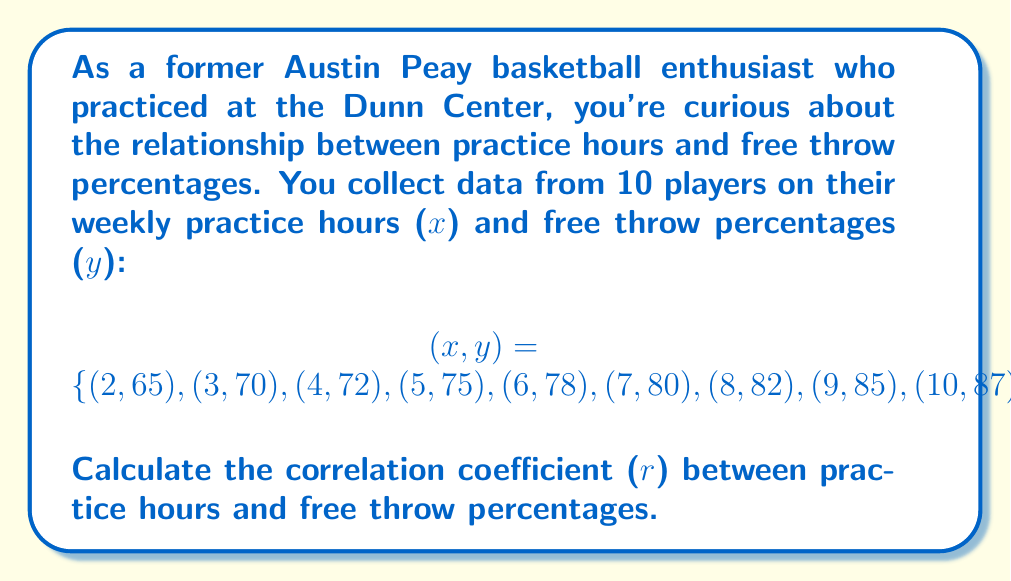Solve this math problem. To calculate the correlation coefficient (r), we'll use the formula:

$$r = \frac{n\sum xy - \sum x \sum y}{\sqrt{[n\sum x^2 - (\sum x)^2][n\sum y^2 - (\sum y)^2]}}$$

Step 1: Calculate the sums and squared sums:
$\sum x = 65$, $\sum y = 784$, $\sum xy = 5,434$
$\sum x^2 = 505$, $\sum y^2 = 62,230$

Step 2: Calculate $n\sum xy$:
$n\sum xy = 10 \times 5,434 = 54,340$

Step 3: Calculate $\sum x \sum y$:
$\sum x \sum y = 65 \times 784 = 50,960$

Step 4: Calculate the numerator:
$n\sum xy - \sum x \sum y = 54,340 - 50,960 = 3,380$

Step 5: Calculate the denominator parts:
$n\sum x^2 - (\sum x)^2 = 10 \times 505 - 65^2 = 5,050 - 4,225 = 825$
$n\sum y^2 - (\sum y)^2 = 10 \times 62,230 - 784^2 = 622,300 - 614,656 = 7,644$

Step 6: Calculate the denominator:
$\sqrt{825 \times 7,644} = \sqrt{6,306,300} \approx 2,511.23$

Step 7: Calculate the correlation coefficient:
$$r = \frac{3,380}{2,511.23} \approx 0.9954$$
Answer: $r \approx 0.9954$ 